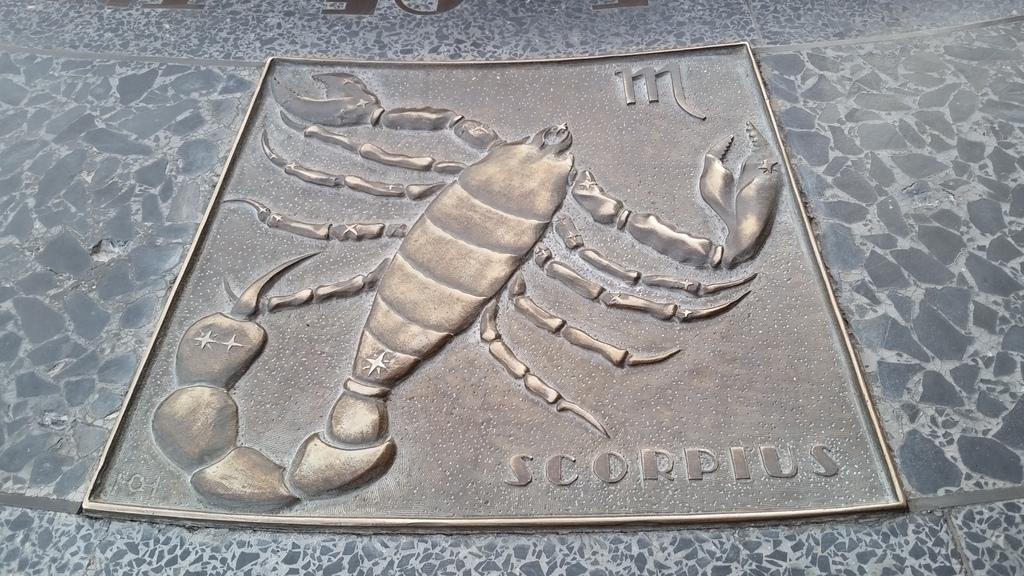What is the main subject of the image? There is a scorpion in the image. What is the scorpion resting on? The scorpion is on an iron material. Can you describe the scorpion's location in the image? The scorpion is on a surface. What type of veil is draped over the scorpion in the image? There is no veil present in the image; the scorpion is resting on an iron material. How is the scorpion being sorted in the image? The scorpion is not being sorted in the image; it is simply resting on a surface. 